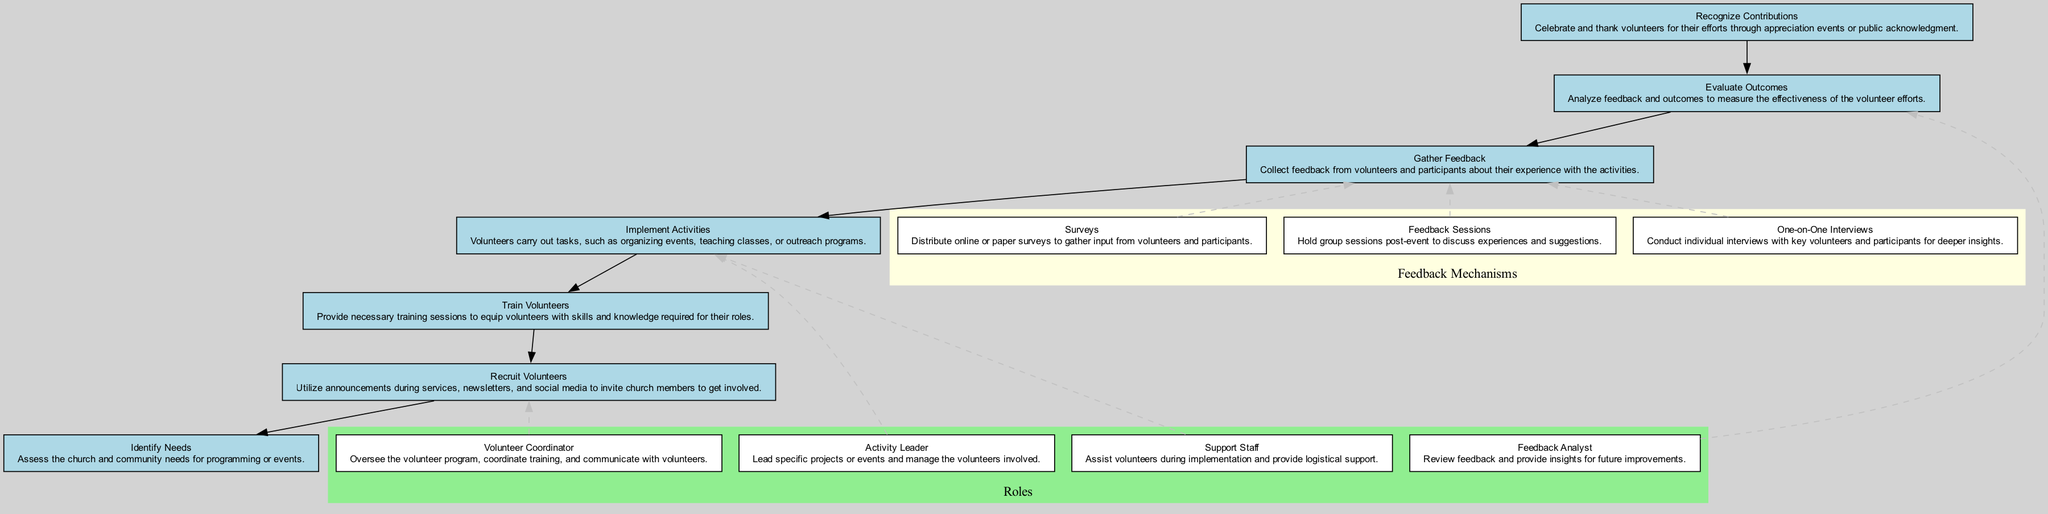What is the first step in the volunteer engagement process? The first step listed in the diagram is "Identify Needs," which involves assessing the church and community needs for programming or events.
Answer: Identify Needs How many steps are there in the volunteer engagement process? By counting the steps shown in the diagram, there are a total of seven steps in the volunteer engagement process.
Answer: 7 Which role is responsible for overseeing the volunteer program? The role responsible for overseeing the volunteer program is the "Volunteer Coordinator," as stated in the diagram.
Answer: Volunteer Coordinator What type of feedback mechanism involves group discussions? The mechanism that involves group discussions is called "Feedback Sessions," as indicated in the diagram.
Answer: Feedback Sessions What step comes directly after "Recruit Volunteers"? The step that comes directly after "Recruit Volunteers" is "Train Volunteers," based on the flow of the diagram.
Answer: Train Volunteers Which feedback mechanism offers deeper insights through individual conversations? The feedback mechanism that provides deeper insights through individual conversations is "One-on-One Interviews," as mentioned in the diagram.
Answer: One-on-One Interviews Which role is linked to managing the volunteers involved in specific projects? The role that is linked to managing the volunteers involved in specific projects is the "Activity Leader," according to the diagram.
Answer: Activity Leader How do "Surveys" gather feedback in the process? "Surveys" gather feedback by distributing online or paper surveys to volunteers and participants, as described in the diagram.
Answer: Distribute surveys What is the final step in the volunteer engagement process? The final step illustrated in the diagram is "Recognize Contributions," which involves celebrating and thanking volunteers for their efforts.
Answer: Recognize Contributions 